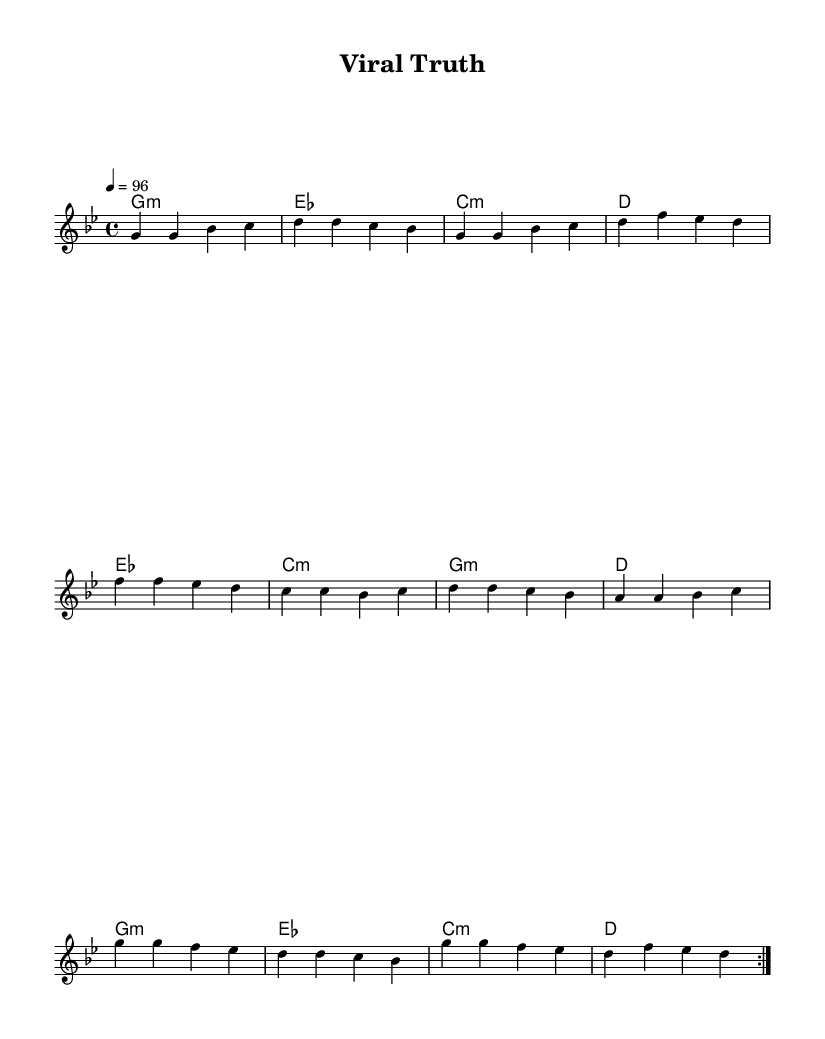What is the key signature of this music? The key signature is G minor, which has two flats (B flat and E flat). This can be inferred from the initial part of the score where the key signature is indicated.
Answer: G minor What is the time signature of this music? The time signature is 4/4, as indicated at the start of the score. This means there are four beats in each measure, and the quarter note gets one beat.
Answer: 4/4 What is the tempo marking of this music? The tempo marking is 96 beats per minute, specified in the score, which indicates how fast the piece should be played.
Answer: 96 How many different sections are there in the melody? The melody contains three distinct sections: Verse, Pre-Chorus, and Chorus, as outlined in the structure of the music. Each section has a unique melodic line.
Answer: 3 What is the harmonic progression used in the verse? The harmonic progression for the verse is G minor, E flat major, C minor, and D major, indicated in the chord section. These chords provide a foundation for the melody.
Answer: G minor, E flat major, C minor, D major Which section of the music utilizes an ascending melodic pattern? The Pre-Chorus section features an ascending melodic pattern leading into the Chorus, where the notes generally rise in pitch, creating an uplifting feel.
Answer: Pre-Chorus In which section do the chord changes occur the most frequently? The Verse section has the most frequent chord changes, as it introduces new chords with each measure compared to the others.
Answer: Verse 